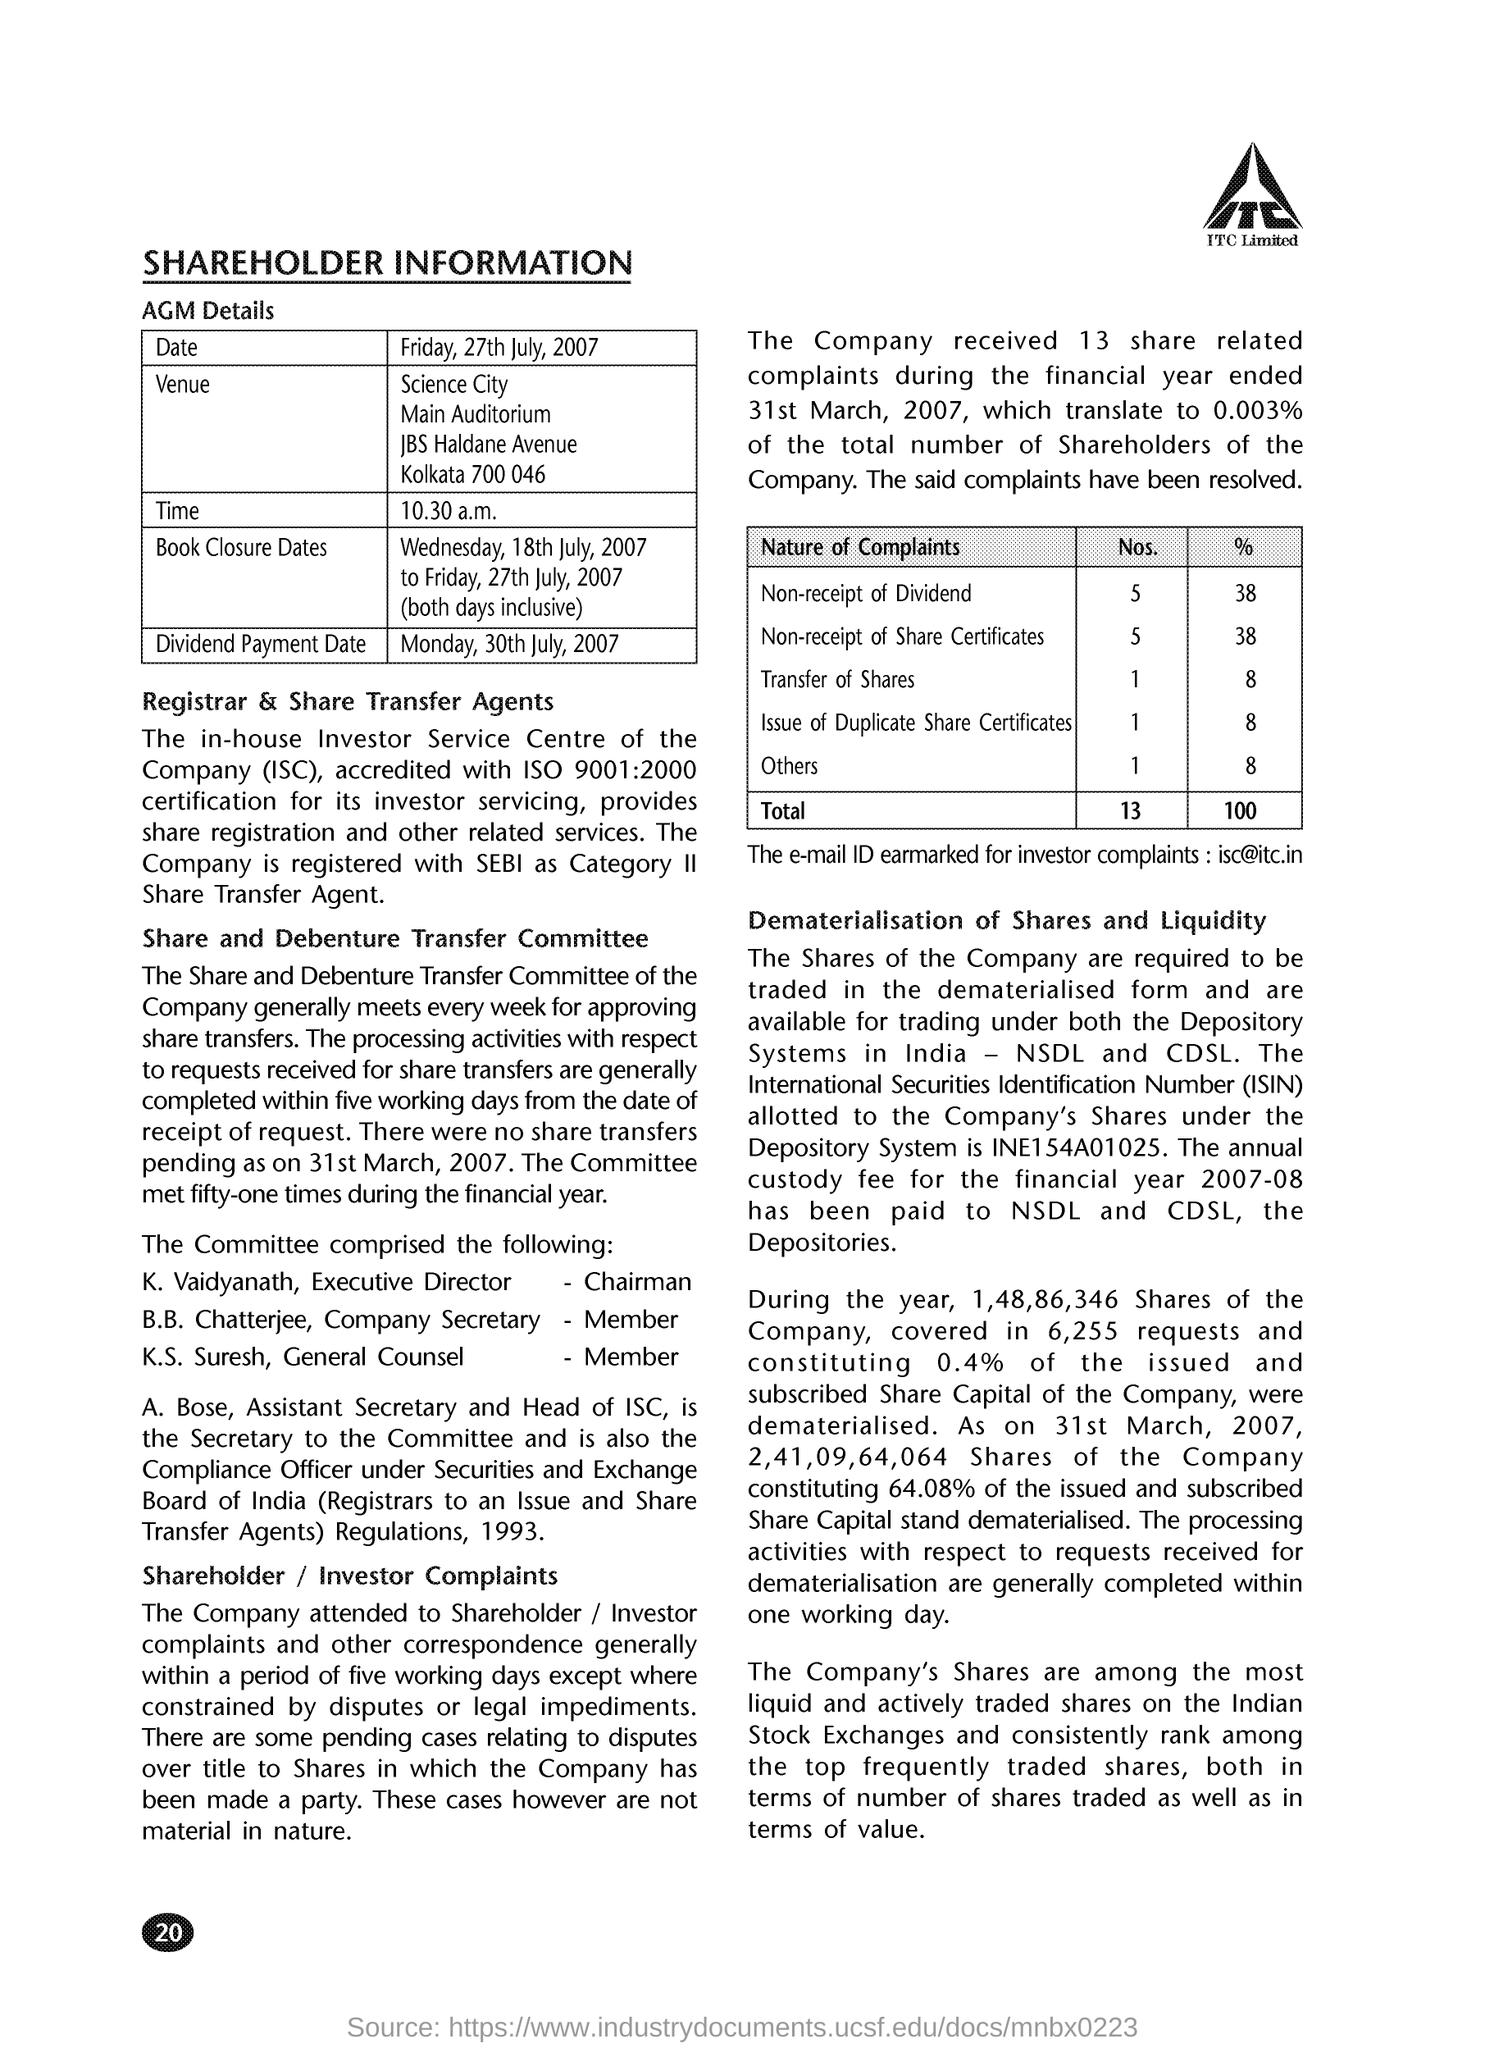What is the email ID for investor complaint?
Your response must be concise. Isc@itc.in. Who is General Counsel member?
Provide a succinct answer. K.S. Suresh. 